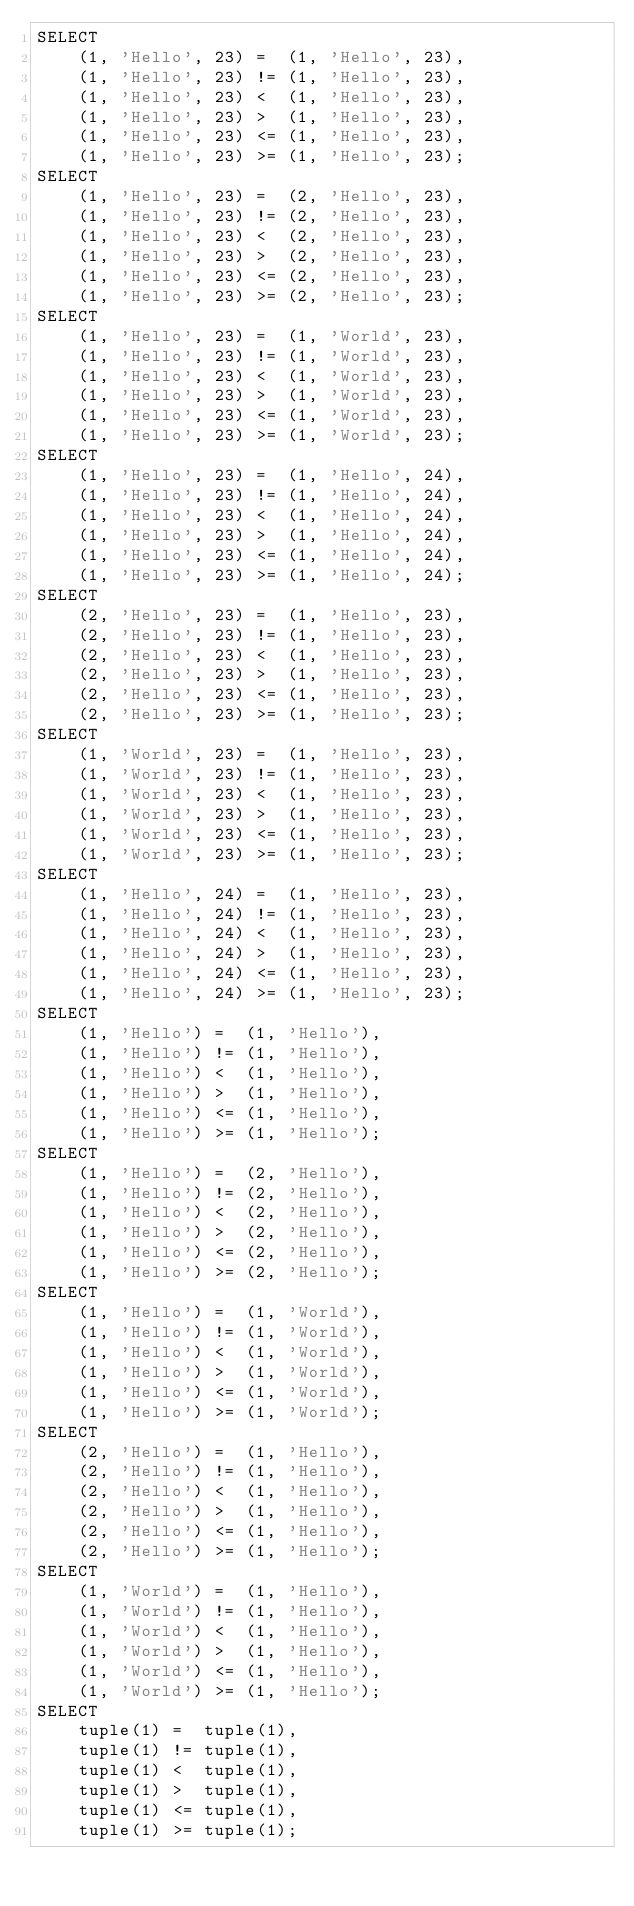<code> <loc_0><loc_0><loc_500><loc_500><_SQL_>SELECT
    (1, 'Hello', 23) =  (1, 'Hello', 23),
    (1, 'Hello', 23) != (1, 'Hello', 23),
    (1, 'Hello', 23) <  (1, 'Hello', 23),
    (1, 'Hello', 23) >  (1, 'Hello', 23),
    (1, 'Hello', 23) <= (1, 'Hello', 23),
    (1, 'Hello', 23) >= (1, 'Hello', 23);
SELECT
    (1, 'Hello', 23) =  (2, 'Hello', 23),
    (1, 'Hello', 23) != (2, 'Hello', 23),
    (1, 'Hello', 23) <  (2, 'Hello', 23),
    (1, 'Hello', 23) >  (2, 'Hello', 23),
    (1, 'Hello', 23) <= (2, 'Hello', 23),
    (1, 'Hello', 23) >= (2, 'Hello', 23);
SELECT
    (1, 'Hello', 23) =  (1, 'World', 23),
    (1, 'Hello', 23) != (1, 'World', 23),
    (1, 'Hello', 23) <  (1, 'World', 23),
    (1, 'Hello', 23) >  (1, 'World', 23),
    (1, 'Hello', 23) <= (1, 'World', 23),
    (1, 'Hello', 23) >= (1, 'World', 23);
SELECT
    (1, 'Hello', 23) =  (1, 'Hello', 24),
    (1, 'Hello', 23) != (1, 'Hello', 24),
    (1, 'Hello', 23) <  (1, 'Hello', 24),
    (1, 'Hello', 23) >  (1, 'Hello', 24),
    (1, 'Hello', 23) <= (1, 'Hello', 24),
    (1, 'Hello', 23) >= (1, 'Hello', 24);
SELECT
    (2, 'Hello', 23) =  (1, 'Hello', 23),
    (2, 'Hello', 23) != (1, 'Hello', 23),
    (2, 'Hello', 23) <  (1, 'Hello', 23),
    (2, 'Hello', 23) >  (1, 'Hello', 23),
    (2, 'Hello', 23) <= (1, 'Hello', 23),
    (2, 'Hello', 23) >= (1, 'Hello', 23);
SELECT
    (1, 'World', 23) =  (1, 'Hello', 23),
    (1, 'World', 23) != (1, 'Hello', 23),
    (1, 'World', 23) <  (1, 'Hello', 23),
    (1, 'World', 23) >  (1, 'Hello', 23),
    (1, 'World', 23) <= (1, 'Hello', 23),
    (1, 'World', 23) >= (1, 'Hello', 23);
SELECT
    (1, 'Hello', 24) =  (1, 'Hello', 23),
    (1, 'Hello', 24) != (1, 'Hello', 23),
    (1, 'Hello', 24) <  (1, 'Hello', 23),
    (1, 'Hello', 24) >  (1, 'Hello', 23),
    (1, 'Hello', 24) <= (1, 'Hello', 23),
    (1, 'Hello', 24) >= (1, 'Hello', 23);
SELECT
    (1, 'Hello') =  (1, 'Hello'),
    (1, 'Hello') != (1, 'Hello'),
    (1, 'Hello') <  (1, 'Hello'),
    (1, 'Hello') >  (1, 'Hello'),
    (1, 'Hello') <= (1, 'Hello'),
    (1, 'Hello') >= (1, 'Hello');
SELECT
    (1, 'Hello') =  (2, 'Hello'),
    (1, 'Hello') != (2, 'Hello'),
    (1, 'Hello') <  (2, 'Hello'),
    (1, 'Hello') >  (2, 'Hello'),
    (1, 'Hello') <= (2, 'Hello'),
    (1, 'Hello') >= (2, 'Hello');
SELECT
    (1, 'Hello') =  (1, 'World'),
    (1, 'Hello') != (1, 'World'),
    (1, 'Hello') <  (1, 'World'),
    (1, 'Hello') >  (1, 'World'),
    (1, 'Hello') <= (1, 'World'),
    (1, 'Hello') >= (1, 'World');
SELECT
    (2, 'Hello') =  (1, 'Hello'),
    (2, 'Hello') != (1, 'Hello'),
    (2, 'Hello') <  (1, 'Hello'),
    (2, 'Hello') >  (1, 'Hello'),
    (2, 'Hello') <= (1, 'Hello'),
    (2, 'Hello') >= (1, 'Hello');
SELECT
    (1, 'World') =  (1, 'Hello'),
    (1, 'World') != (1, 'Hello'),
    (1, 'World') <  (1, 'Hello'),
    (1, 'World') >  (1, 'Hello'),
    (1, 'World') <= (1, 'Hello'),
    (1, 'World') >= (1, 'Hello');
SELECT
    tuple(1) =  tuple(1),
    tuple(1) != tuple(1),
    tuple(1) <  tuple(1),
    tuple(1) >  tuple(1),
    tuple(1) <= tuple(1),
    tuple(1) >= tuple(1);</code> 